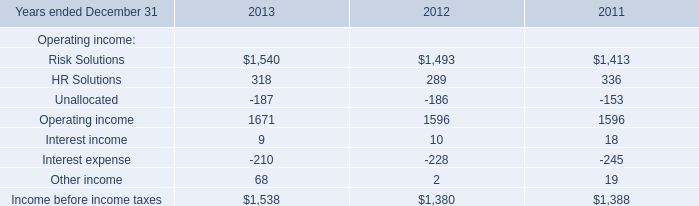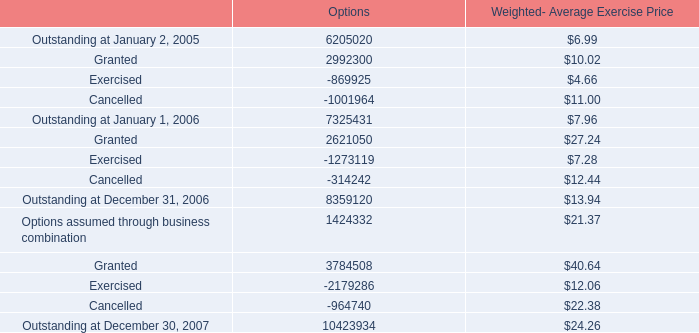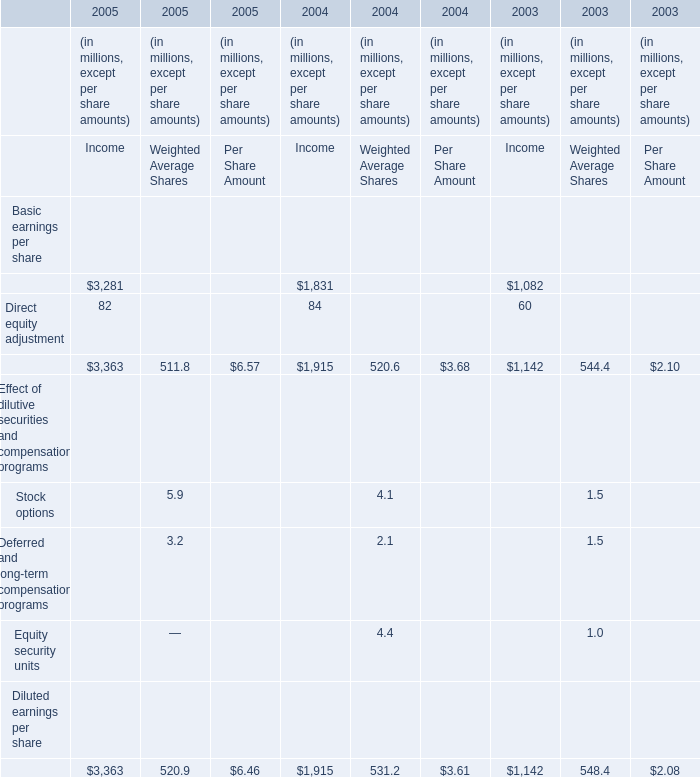What's the sum of Income before income taxes of 2013, Outstanding at December 31, 2006 of Options, and Risk Solutions of 2013 ? 
Computations: ((1538.0 + 8359120.0) + 1540.0)
Answer: 8362198.0. 